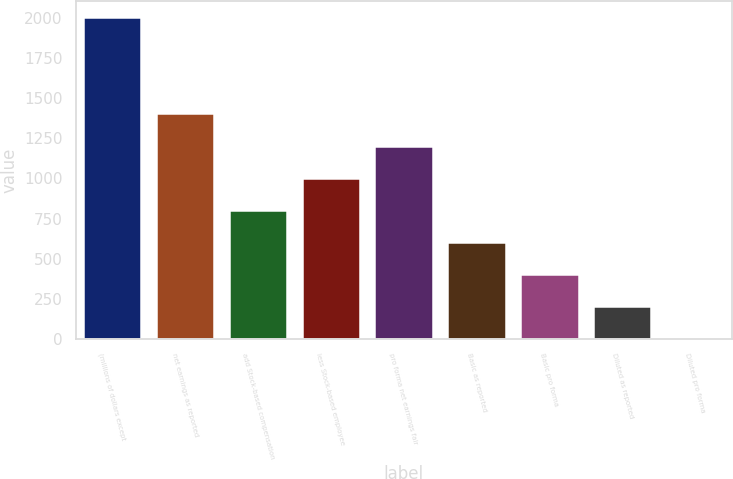<chart> <loc_0><loc_0><loc_500><loc_500><bar_chart><fcel>(millions of dollars except<fcel>net earnings as reported<fcel>add Stock-based compensation<fcel>less Stock-based employee<fcel>pro forma net earnings fair<fcel>Basic as reported<fcel>Basic pro forma<fcel>Diluted as reported<fcel>Diluted pro forma<nl><fcel>2005<fcel>1404.42<fcel>803.85<fcel>1004.04<fcel>1204.23<fcel>603.66<fcel>403.47<fcel>203.28<fcel>3.09<nl></chart> 